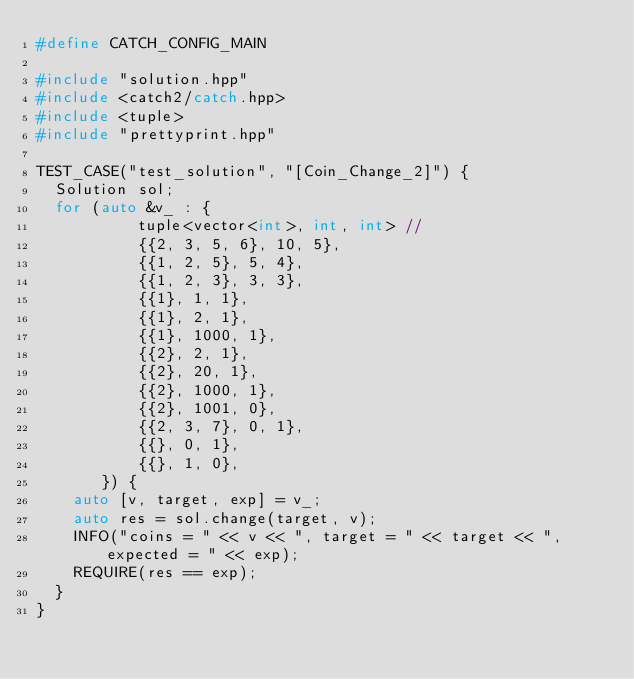Convert code to text. <code><loc_0><loc_0><loc_500><loc_500><_C++_>#define CATCH_CONFIG_MAIN

#include "solution.hpp"
#include <catch2/catch.hpp>
#include <tuple>
#include "prettyprint.hpp"

TEST_CASE("test_solution", "[Coin_Change_2]") {
  Solution sol;
  for (auto &v_ : {
           tuple<vector<int>, int, int> //
           {{2, 3, 5, 6}, 10, 5},
           {{1, 2, 5}, 5, 4},
           {{1, 2, 3}, 3, 3},
           {{1}, 1, 1},
           {{1}, 2, 1},
           {{1}, 1000, 1},
           {{2}, 2, 1},
           {{2}, 20, 1},
           {{2}, 1000, 1},
           {{2}, 1001, 0},
           {{2, 3, 7}, 0, 1},
           {{}, 0, 1},
           {{}, 1, 0},
       }) {
    auto [v, target, exp] = v_;
    auto res = sol.change(target, v);
    INFO("coins = " << v << ", target = " << target << ", expected = " << exp);
    REQUIRE(res == exp);
  }
}
</code> 